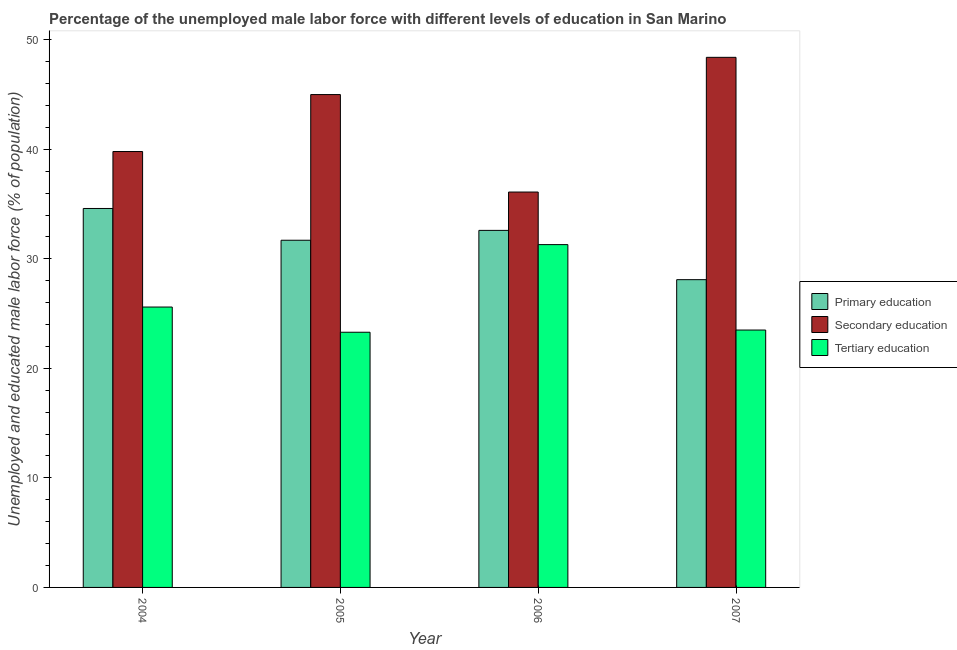How many bars are there on the 2nd tick from the left?
Provide a succinct answer. 3. How many bars are there on the 2nd tick from the right?
Your answer should be compact. 3. What is the label of the 4th group of bars from the left?
Keep it short and to the point. 2007. In how many cases, is the number of bars for a given year not equal to the number of legend labels?
Give a very brief answer. 0. Across all years, what is the maximum percentage of male labor force who received primary education?
Provide a short and direct response. 34.6. Across all years, what is the minimum percentage of male labor force who received tertiary education?
Offer a very short reply. 23.3. In which year was the percentage of male labor force who received tertiary education maximum?
Give a very brief answer. 2006. What is the total percentage of male labor force who received primary education in the graph?
Offer a very short reply. 127. What is the difference between the percentage of male labor force who received tertiary education in 2004 and that in 2005?
Your answer should be very brief. 2.3. What is the difference between the percentage of male labor force who received primary education in 2004 and the percentage of male labor force who received secondary education in 2005?
Offer a very short reply. 2.9. What is the average percentage of male labor force who received secondary education per year?
Provide a succinct answer. 42.32. In how many years, is the percentage of male labor force who received secondary education greater than 34 %?
Keep it short and to the point. 4. What is the ratio of the percentage of male labor force who received primary education in 2006 to that in 2007?
Your response must be concise. 1.16. What is the difference between the highest and the second highest percentage of male labor force who received secondary education?
Provide a short and direct response. 3.4. What is the difference between the highest and the lowest percentage of male labor force who received secondary education?
Ensure brevity in your answer.  12.3. What does the 2nd bar from the right in 2004 represents?
Make the answer very short. Secondary education. Is it the case that in every year, the sum of the percentage of male labor force who received primary education and percentage of male labor force who received secondary education is greater than the percentage of male labor force who received tertiary education?
Provide a short and direct response. Yes. How many bars are there?
Your answer should be very brief. 12. Are all the bars in the graph horizontal?
Make the answer very short. No. How many years are there in the graph?
Give a very brief answer. 4. What is the difference between two consecutive major ticks on the Y-axis?
Offer a terse response. 10. Are the values on the major ticks of Y-axis written in scientific E-notation?
Give a very brief answer. No. Does the graph contain grids?
Provide a succinct answer. No. Where does the legend appear in the graph?
Give a very brief answer. Center right. How many legend labels are there?
Make the answer very short. 3. What is the title of the graph?
Give a very brief answer. Percentage of the unemployed male labor force with different levels of education in San Marino. What is the label or title of the Y-axis?
Make the answer very short. Unemployed and educated male labor force (% of population). What is the Unemployed and educated male labor force (% of population) in Primary education in 2004?
Your answer should be very brief. 34.6. What is the Unemployed and educated male labor force (% of population) of Secondary education in 2004?
Your answer should be very brief. 39.8. What is the Unemployed and educated male labor force (% of population) in Tertiary education in 2004?
Provide a succinct answer. 25.6. What is the Unemployed and educated male labor force (% of population) of Primary education in 2005?
Your answer should be compact. 31.7. What is the Unemployed and educated male labor force (% of population) in Tertiary education in 2005?
Make the answer very short. 23.3. What is the Unemployed and educated male labor force (% of population) of Primary education in 2006?
Ensure brevity in your answer.  32.6. What is the Unemployed and educated male labor force (% of population) in Secondary education in 2006?
Offer a very short reply. 36.1. What is the Unemployed and educated male labor force (% of population) of Tertiary education in 2006?
Make the answer very short. 31.3. What is the Unemployed and educated male labor force (% of population) in Primary education in 2007?
Offer a terse response. 28.1. What is the Unemployed and educated male labor force (% of population) of Secondary education in 2007?
Offer a terse response. 48.4. What is the Unemployed and educated male labor force (% of population) of Tertiary education in 2007?
Your response must be concise. 23.5. Across all years, what is the maximum Unemployed and educated male labor force (% of population) of Primary education?
Give a very brief answer. 34.6. Across all years, what is the maximum Unemployed and educated male labor force (% of population) of Secondary education?
Provide a succinct answer. 48.4. Across all years, what is the maximum Unemployed and educated male labor force (% of population) of Tertiary education?
Keep it short and to the point. 31.3. Across all years, what is the minimum Unemployed and educated male labor force (% of population) in Primary education?
Keep it short and to the point. 28.1. Across all years, what is the minimum Unemployed and educated male labor force (% of population) of Secondary education?
Offer a very short reply. 36.1. Across all years, what is the minimum Unemployed and educated male labor force (% of population) of Tertiary education?
Ensure brevity in your answer.  23.3. What is the total Unemployed and educated male labor force (% of population) of Primary education in the graph?
Offer a very short reply. 127. What is the total Unemployed and educated male labor force (% of population) of Secondary education in the graph?
Keep it short and to the point. 169.3. What is the total Unemployed and educated male labor force (% of population) of Tertiary education in the graph?
Offer a terse response. 103.7. What is the difference between the Unemployed and educated male labor force (% of population) of Secondary education in 2004 and that in 2005?
Offer a terse response. -5.2. What is the difference between the Unemployed and educated male labor force (% of population) of Primary education in 2004 and that in 2006?
Offer a very short reply. 2. What is the difference between the Unemployed and educated male labor force (% of population) in Secondary education in 2004 and that in 2006?
Your response must be concise. 3.7. What is the difference between the Unemployed and educated male labor force (% of population) in Tertiary education in 2004 and that in 2006?
Your answer should be compact. -5.7. What is the difference between the Unemployed and educated male labor force (% of population) in Tertiary education in 2004 and that in 2007?
Your answer should be very brief. 2.1. What is the difference between the Unemployed and educated male labor force (% of population) of Primary education in 2005 and that in 2006?
Keep it short and to the point. -0.9. What is the difference between the Unemployed and educated male labor force (% of population) of Tertiary education in 2005 and that in 2006?
Your answer should be compact. -8. What is the difference between the Unemployed and educated male labor force (% of population) of Secondary education in 2005 and that in 2007?
Ensure brevity in your answer.  -3.4. What is the difference between the Unemployed and educated male labor force (% of population) of Secondary education in 2006 and that in 2007?
Provide a short and direct response. -12.3. What is the difference between the Unemployed and educated male labor force (% of population) in Primary education in 2004 and the Unemployed and educated male labor force (% of population) in Secondary education in 2006?
Offer a very short reply. -1.5. What is the difference between the Unemployed and educated male labor force (% of population) of Secondary education in 2004 and the Unemployed and educated male labor force (% of population) of Tertiary education in 2006?
Ensure brevity in your answer.  8.5. What is the difference between the Unemployed and educated male labor force (% of population) in Primary education in 2004 and the Unemployed and educated male labor force (% of population) in Tertiary education in 2007?
Ensure brevity in your answer.  11.1. What is the difference between the Unemployed and educated male labor force (% of population) of Secondary education in 2004 and the Unemployed and educated male labor force (% of population) of Tertiary education in 2007?
Keep it short and to the point. 16.3. What is the difference between the Unemployed and educated male labor force (% of population) of Primary education in 2005 and the Unemployed and educated male labor force (% of population) of Secondary education in 2006?
Your response must be concise. -4.4. What is the difference between the Unemployed and educated male labor force (% of population) in Primary education in 2005 and the Unemployed and educated male labor force (% of population) in Tertiary education in 2006?
Make the answer very short. 0.4. What is the difference between the Unemployed and educated male labor force (% of population) of Primary education in 2005 and the Unemployed and educated male labor force (% of population) of Secondary education in 2007?
Give a very brief answer. -16.7. What is the difference between the Unemployed and educated male labor force (% of population) in Secondary education in 2005 and the Unemployed and educated male labor force (% of population) in Tertiary education in 2007?
Provide a short and direct response. 21.5. What is the difference between the Unemployed and educated male labor force (% of population) in Primary education in 2006 and the Unemployed and educated male labor force (% of population) in Secondary education in 2007?
Ensure brevity in your answer.  -15.8. What is the difference between the Unemployed and educated male labor force (% of population) in Secondary education in 2006 and the Unemployed and educated male labor force (% of population) in Tertiary education in 2007?
Provide a succinct answer. 12.6. What is the average Unemployed and educated male labor force (% of population) of Primary education per year?
Keep it short and to the point. 31.75. What is the average Unemployed and educated male labor force (% of population) in Secondary education per year?
Keep it short and to the point. 42.33. What is the average Unemployed and educated male labor force (% of population) of Tertiary education per year?
Provide a succinct answer. 25.93. In the year 2005, what is the difference between the Unemployed and educated male labor force (% of population) in Primary education and Unemployed and educated male labor force (% of population) in Tertiary education?
Give a very brief answer. 8.4. In the year 2005, what is the difference between the Unemployed and educated male labor force (% of population) of Secondary education and Unemployed and educated male labor force (% of population) of Tertiary education?
Provide a succinct answer. 21.7. In the year 2006, what is the difference between the Unemployed and educated male labor force (% of population) of Primary education and Unemployed and educated male labor force (% of population) of Secondary education?
Your answer should be compact. -3.5. In the year 2006, what is the difference between the Unemployed and educated male labor force (% of population) of Secondary education and Unemployed and educated male labor force (% of population) of Tertiary education?
Your response must be concise. 4.8. In the year 2007, what is the difference between the Unemployed and educated male labor force (% of population) in Primary education and Unemployed and educated male labor force (% of population) in Secondary education?
Your response must be concise. -20.3. In the year 2007, what is the difference between the Unemployed and educated male labor force (% of population) in Primary education and Unemployed and educated male labor force (% of population) in Tertiary education?
Give a very brief answer. 4.6. In the year 2007, what is the difference between the Unemployed and educated male labor force (% of population) in Secondary education and Unemployed and educated male labor force (% of population) in Tertiary education?
Offer a terse response. 24.9. What is the ratio of the Unemployed and educated male labor force (% of population) of Primary education in 2004 to that in 2005?
Your response must be concise. 1.09. What is the ratio of the Unemployed and educated male labor force (% of population) of Secondary education in 2004 to that in 2005?
Provide a short and direct response. 0.88. What is the ratio of the Unemployed and educated male labor force (% of population) of Tertiary education in 2004 to that in 2005?
Give a very brief answer. 1.1. What is the ratio of the Unemployed and educated male labor force (% of population) in Primary education in 2004 to that in 2006?
Make the answer very short. 1.06. What is the ratio of the Unemployed and educated male labor force (% of population) of Secondary education in 2004 to that in 2006?
Offer a terse response. 1.1. What is the ratio of the Unemployed and educated male labor force (% of population) in Tertiary education in 2004 to that in 2006?
Ensure brevity in your answer.  0.82. What is the ratio of the Unemployed and educated male labor force (% of population) in Primary education in 2004 to that in 2007?
Keep it short and to the point. 1.23. What is the ratio of the Unemployed and educated male labor force (% of population) of Secondary education in 2004 to that in 2007?
Make the answer very short. 0.82. What is the ratio of the Unemployed and educated male labor force (% of population) in Tertiary education in 2004 to that in 2007?
Your answer should be very brief. 1.09. What is the ratio of the Unemployed and educated male labor force (% of population) of Primary education in 2005 to that in 2006?
Keep it short and to the point. 0.97. What is the ratio of the Unemployed and educated male labor force (% of population) in Secondary education in 2005 to that in 2006?
Give a very brief answer. 1.25. What is the ratio of the Unemployed and educated male labor force (% of population) in Tertiary education in 2005 to that in 2006?
Keep it short and to the point. 0.74. What is the ratio of the Unemployed and educated male labor force (% of population) of Primary education in 2005 to that in 2007?
Keep it short and to the point. 1.13. What is the ratio of the Unemployed and educated male labor force (% of population) in Secondary education in 2005 to that in 2007?
Provide a short and direct response. 0.93. What is the ratio of the Unemployed and educated male labor force (% of population) of Primary education in 2006 to that in 2007?
Your response must be concise. 1.16. What is the ratio of the Unemployed and educated male labor force (% of population) of Secondary education in 2006 to that in 2007?
Offer a very short reply. 0.75. What is the ratio of the Unemployed and educated male labor force (% of population) in Tertiary education in 2006 to that in 2007?
Give a very brief answer. 1.33. What is the difference between the highest and the second highest Unemployed and educated male labor force (% of population) of Primary education?
Give a very brief answer. 2. What is the difference between the highest and the lowest Unemployed and educated male labor force (% of population) in Primary education?
Provide a short and direct response. 6.5. What is the difference between the highest and the lowest Unemployed and educated male labor force (% of population) of Secondary education?
Provide a short and direct response. 12.3. 